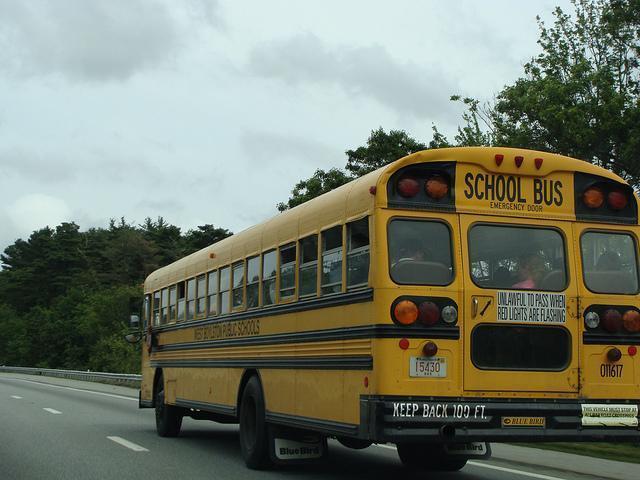How many windows are down?
Give a very brief answer. 5. How many school buses on the street?
Give a very brief answer. 1. 